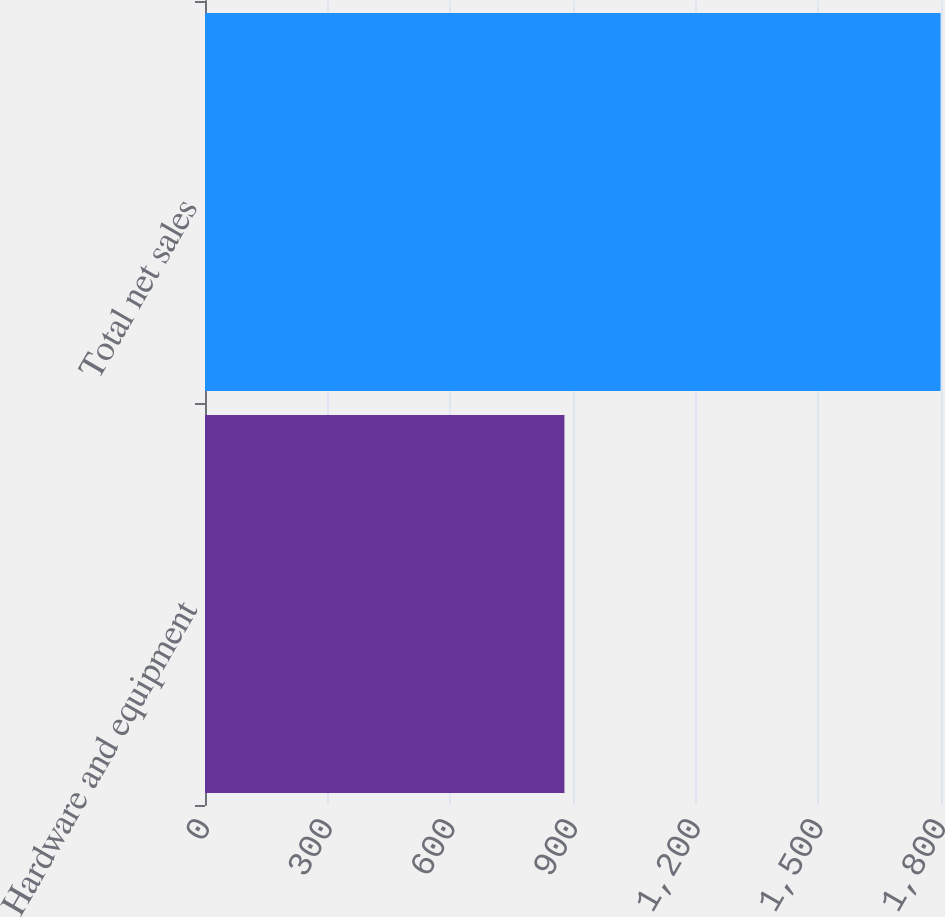Convert chart. <chart><loc_0><loc_0><loc_500><loc_500><bar_chart><fcel>Hardware and equipment<fcel>Total net sales<nl><fcel>879<fcel>1799<nl></chart> 